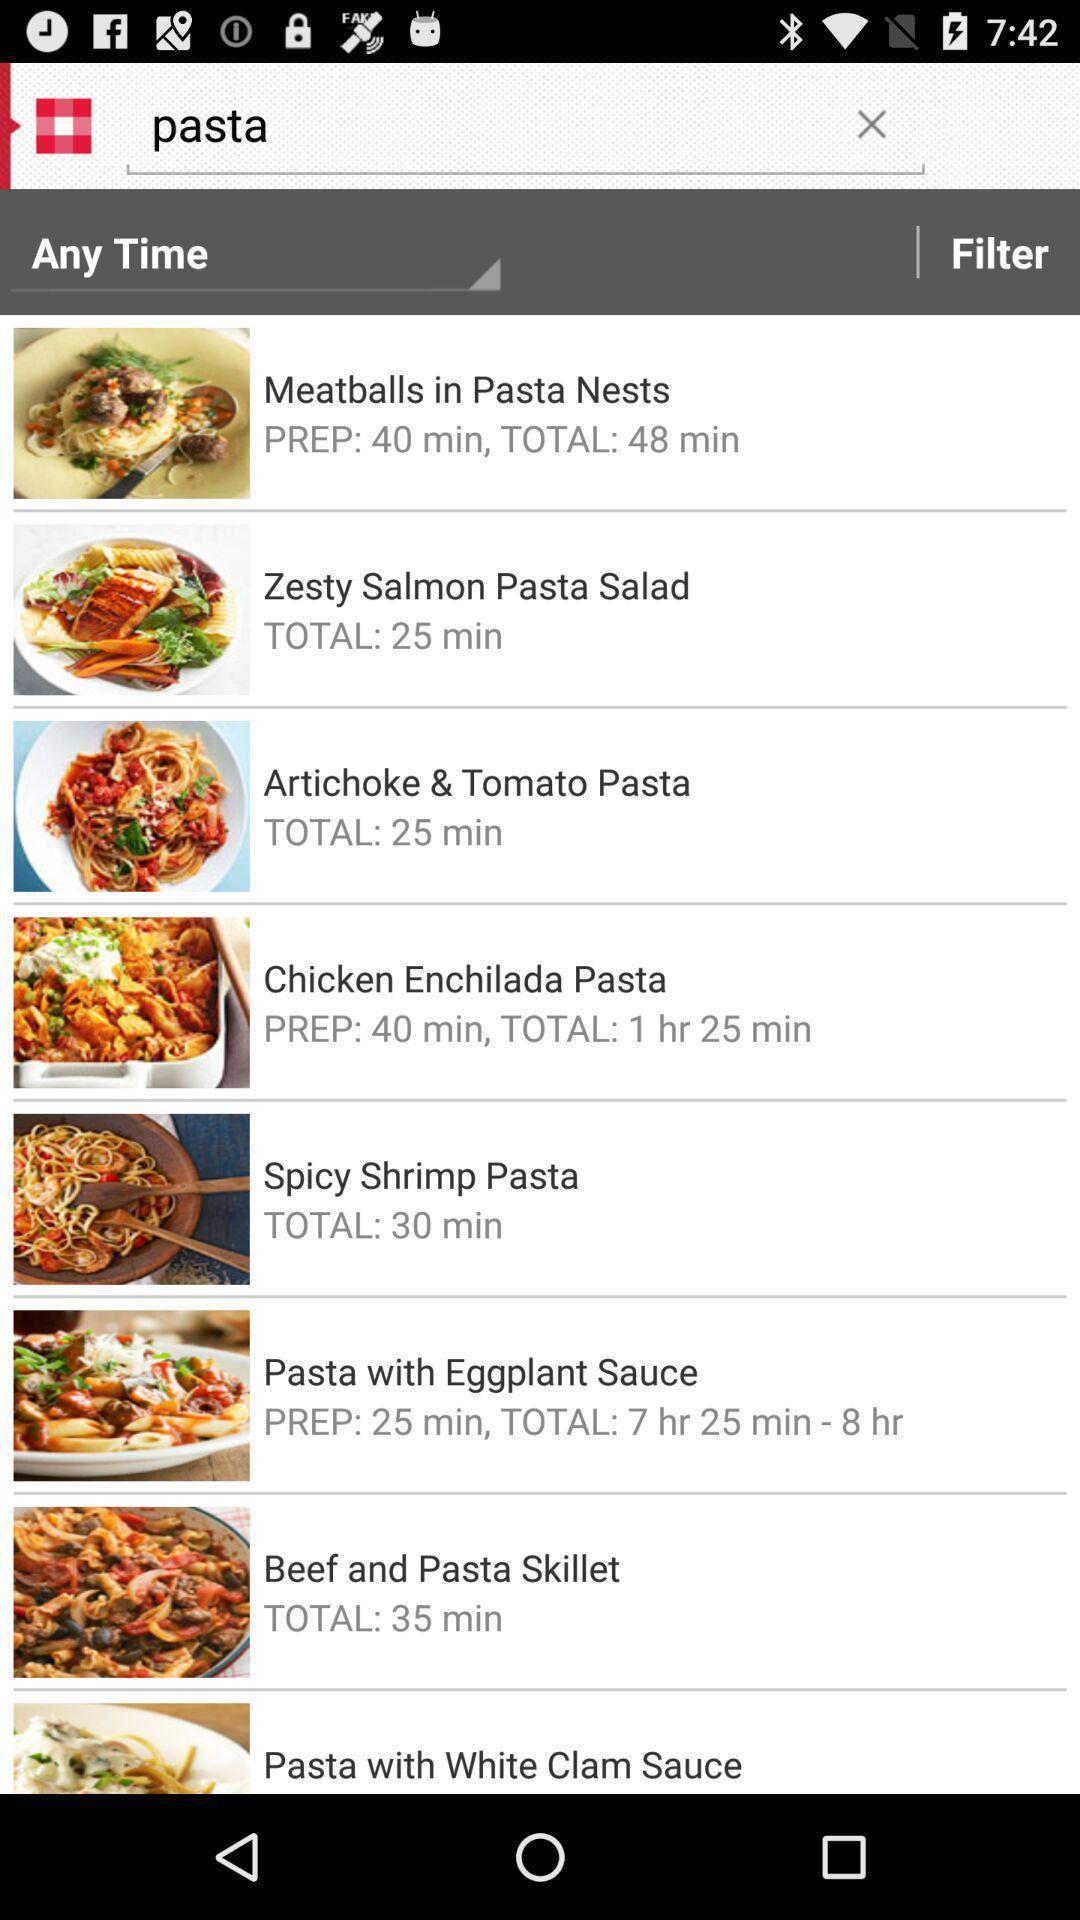Give me a narrative description of this picture. Various cuisines list displayed of a food eatery app. 